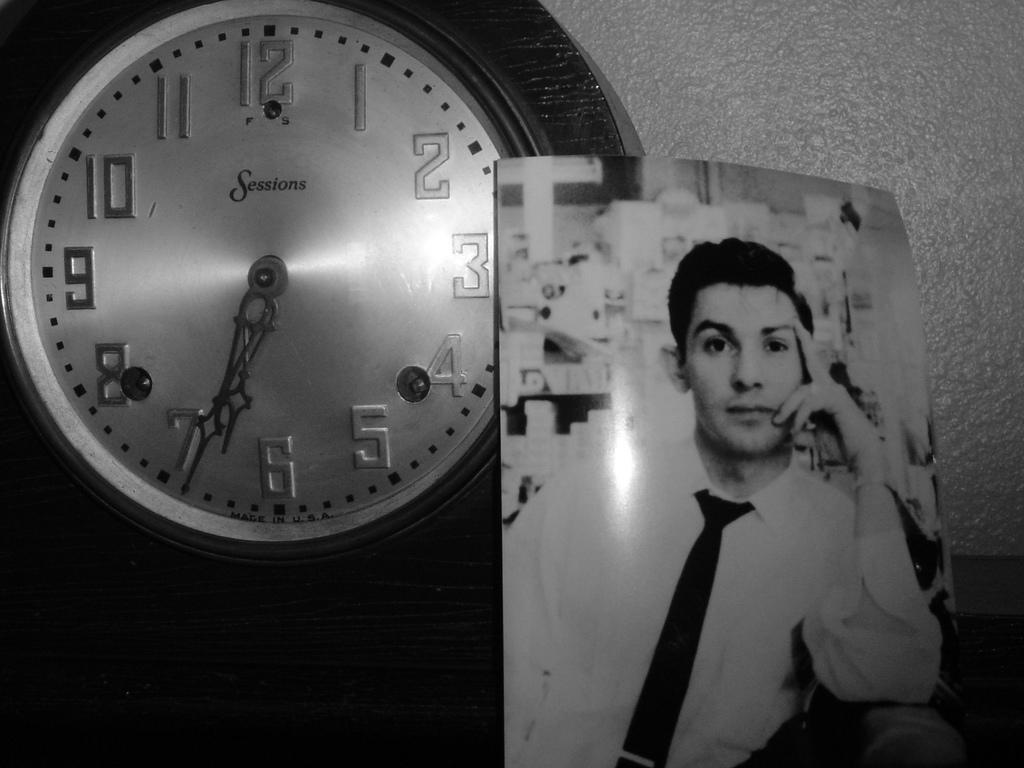Could you give a brief overview of what you see in this image? In the picture we can see a clock near the wall and beside it we can see a photograph of a man sitting and he is with white shirt and tie. 